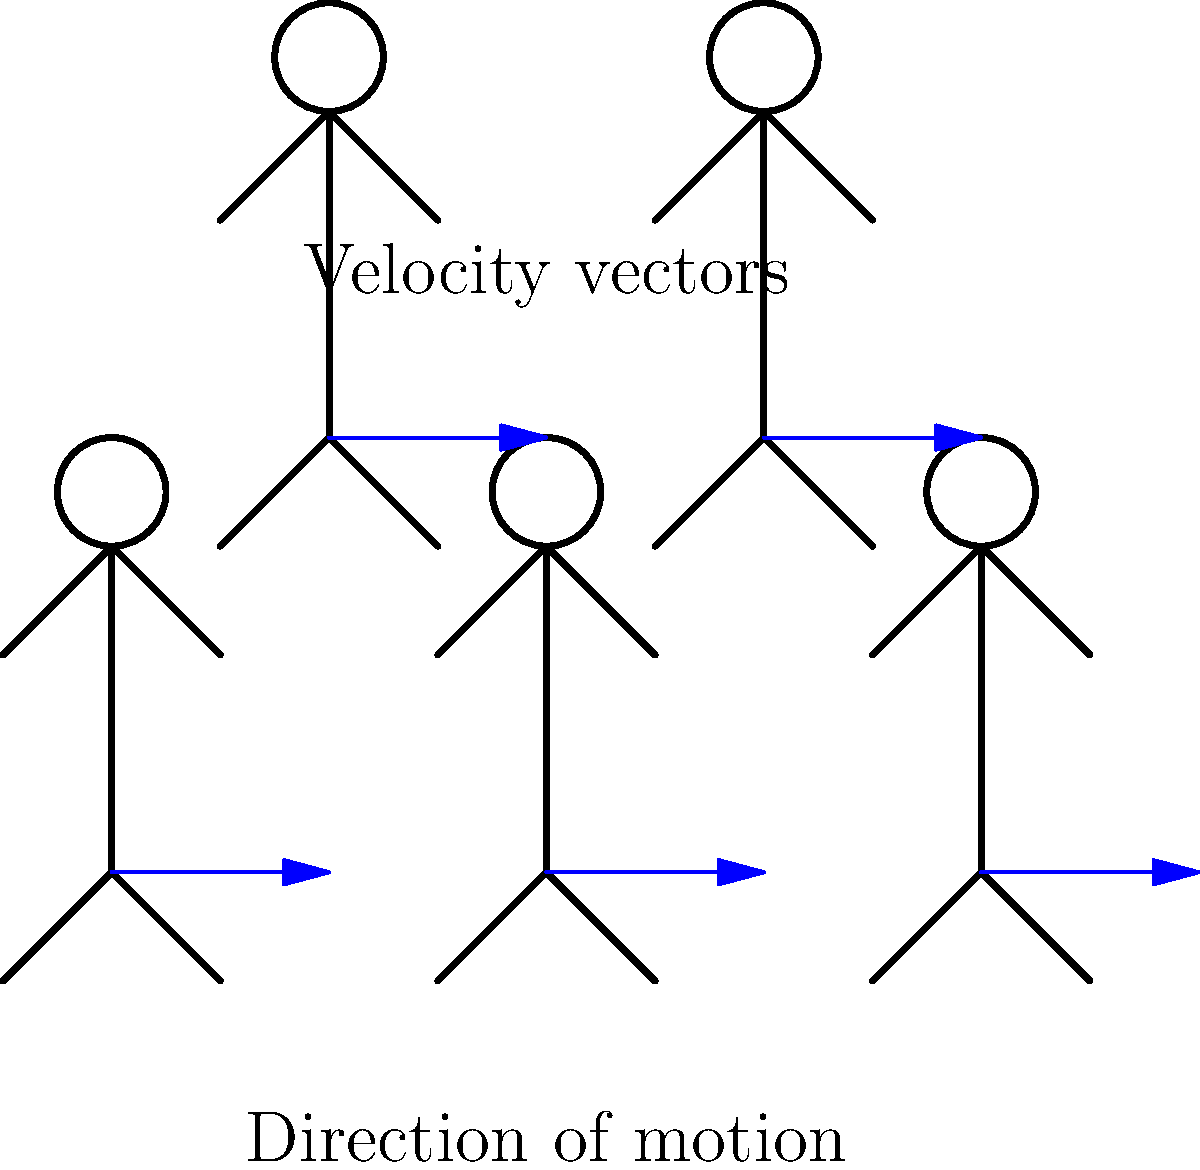In the running stride of a South Sydney Rabbitohs player, as illustrated by the stick figure sequence, how does the horizontal velocity of the player's center of mass typically change throughout a single stride cycle? To understand the horizontal velocity changes in a player's running stride:

1. Observe the stick figure sequence, representing different phases of a running stride.

2. Note the blue arrows, indicating velocity vectors, which are consistent in length across the stride cycle.

3. In reality, a runner's horizontal velocity isn't constant throughout a stride:
   a) It slightly decreases during the braking phase (initial foot contact).
   b) It increases during the propulsion phase (push-off).

4. However, for a skilled runner like a Rabbitohs player:
   a) These velocity fluctuations are minimized for efficiency.
   b) The overall average velocity remains relatively constant.

5. The constant-length velocity vectors in the diagram represent this average velocity over the entire stride cycle.

6. This near-constant average velocity is crucial for maintaining speed in rugby, especially for breakaway runs or chasing down opponents.

Therefore, while there are small fluctuations within each stride, the horizontal velocity of a skilled runner's center of mass remains approximately constant when averaged over a complete stride cycle.
Answer: Approximately constant when averaged over a complete stride cycle. 